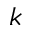<formula> <loc_0><loc_0><loc_500><loc_500>k</formula> 